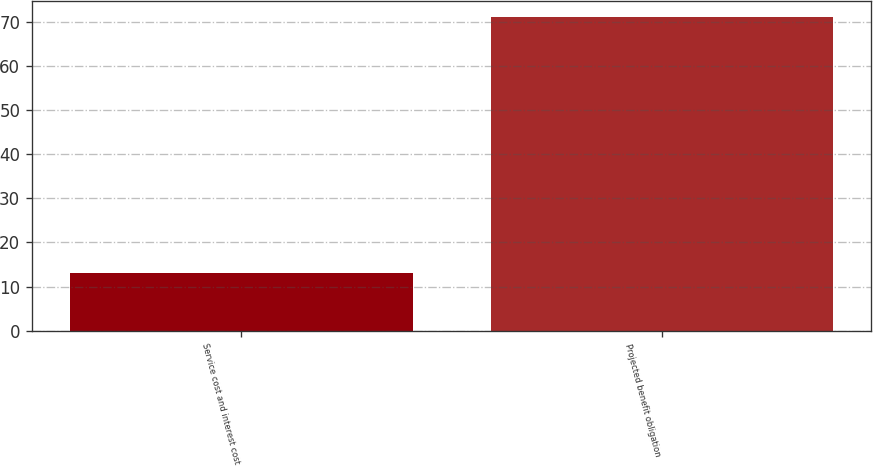Convert chart. <chart><loc_0><loc_0><loc_500><loc_500><bar_chart><fcel>Service cost and interest cost<fcel>Projected benefit obligation<nl><fcel>13<fcel>71<nl></chart> 